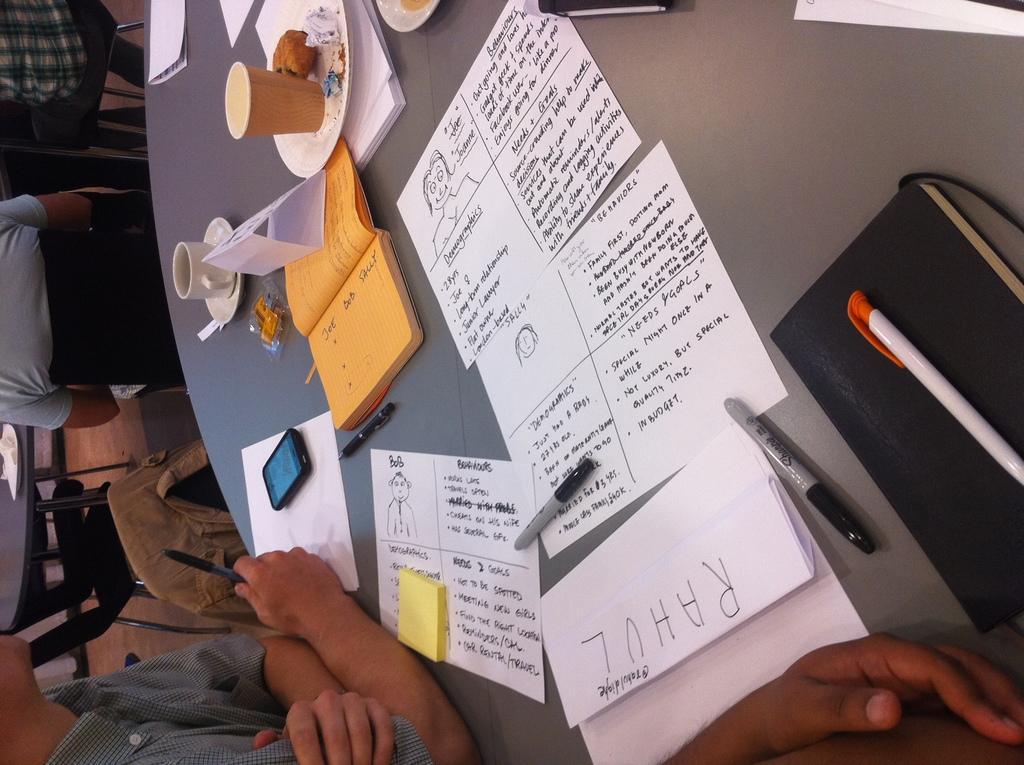How would you summarize this image in a sentence or two? In this picture we have a round table on which many things are kept. There are papers, cups and saucers, books, mobile phone, pen, etc., A person is sitting. 